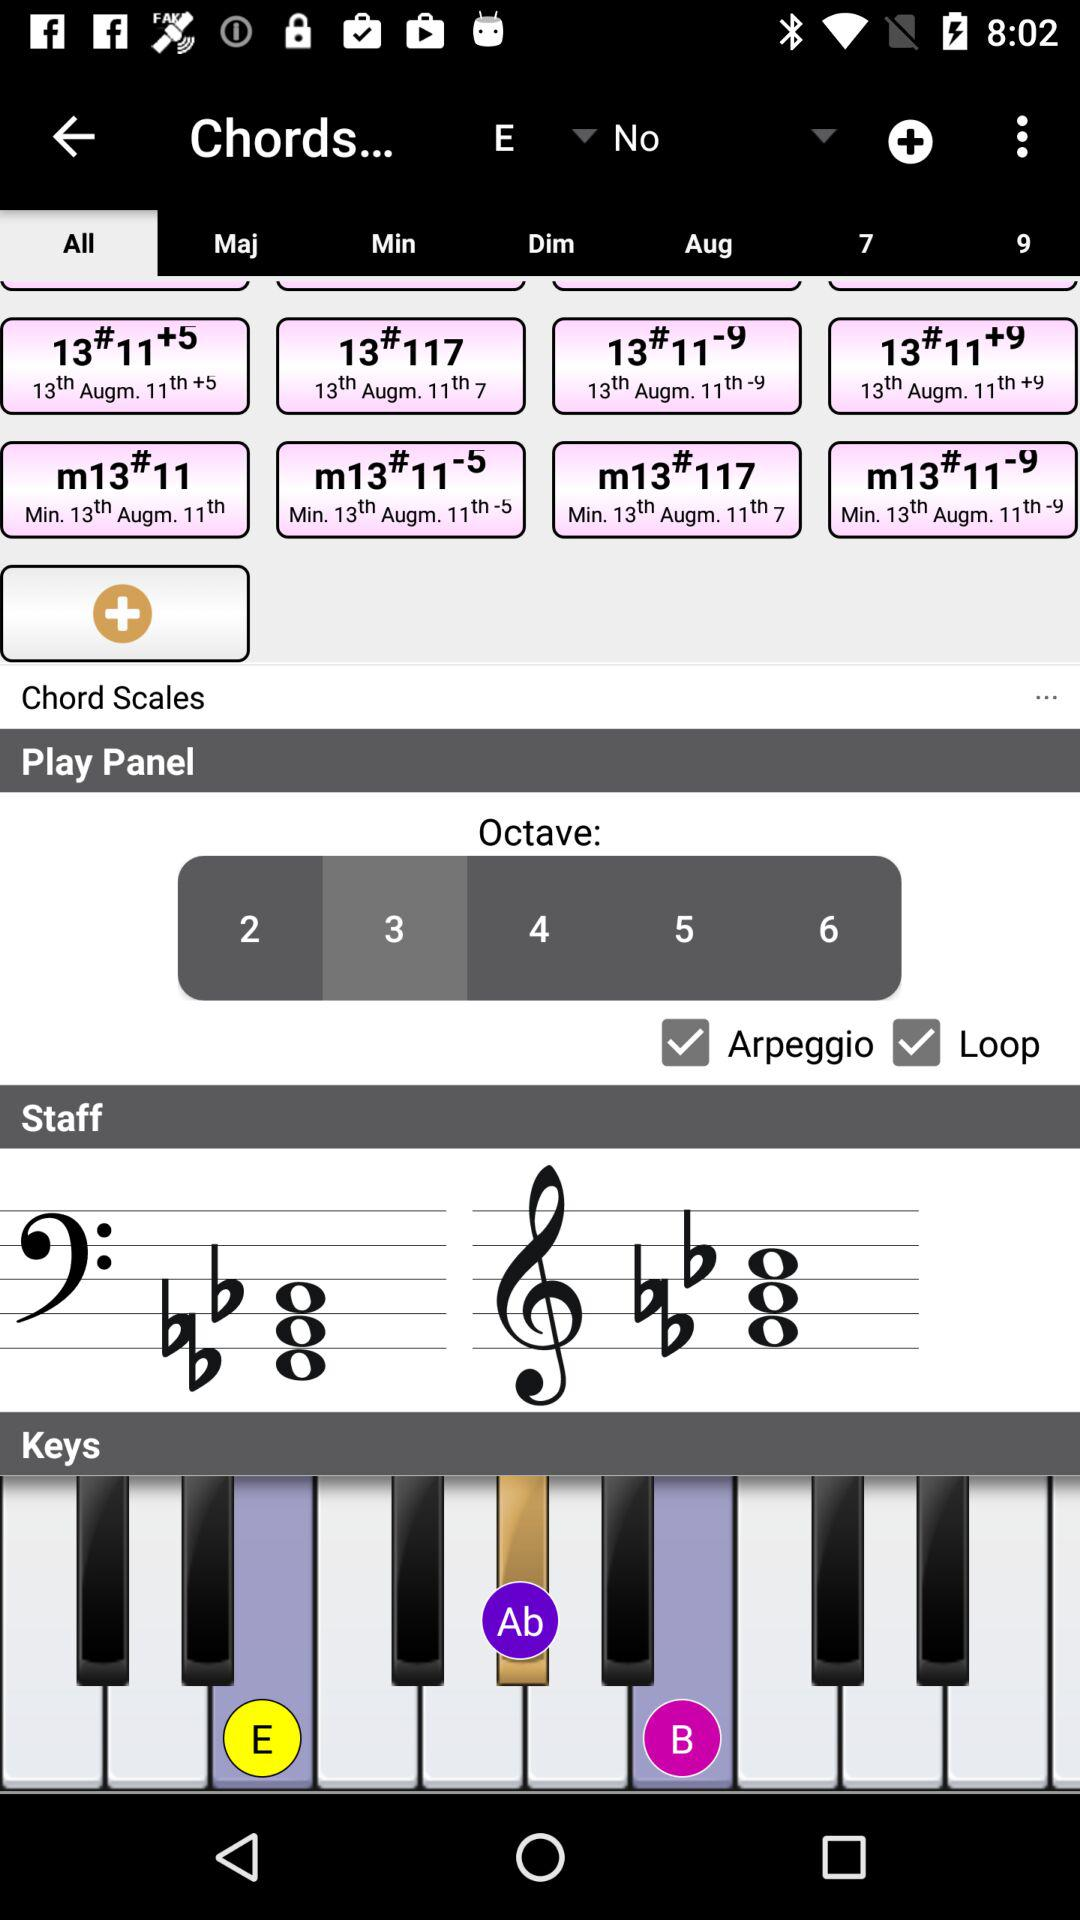Can you explain what the loop feature does in this music app? The loop feature in this music application lets you continuously repeat a selected segment of music. This is particularly useful for practicing specific parts, composing, or arranging music by allowing continuous playback without manual intervention. 